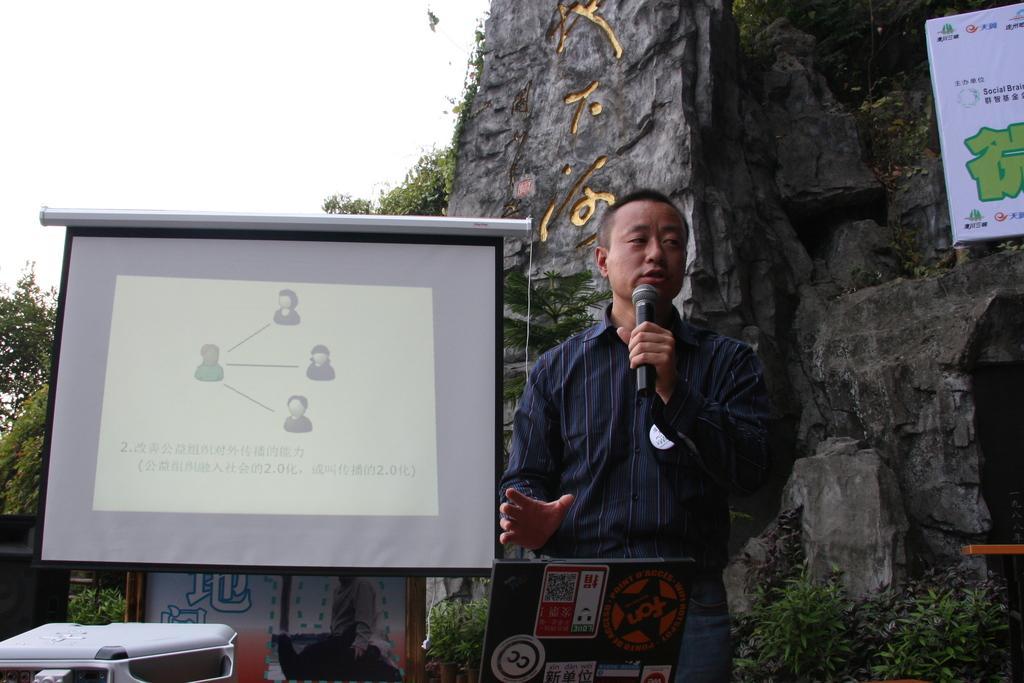Describe this image in one or two sentences. As we can see in the image there is a screen, poster, a man holding mic, banner, tree, plants and trees. On the top there is sky. 